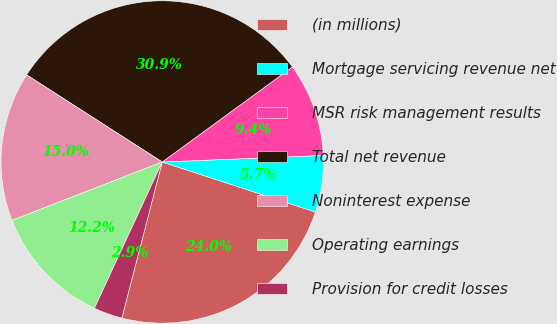<chart> <loc_0><loc_0><loc_500><loc_500><pie_chart><fcel>(in millions)<fcel>Mortgage servicing revenue net<fcel>MSR risk management results<fcel>Total net revenue<fcel>Noninterest expense<fcel>Operating earnings<fcel>Provision for credit losses<nl><fcel>24.0%<fcel>5.67%<fcel>9.39%<fcel>30.87%<fcel>14.99%<fcel>12.19%<fcel>2.88%<nl></chart> 